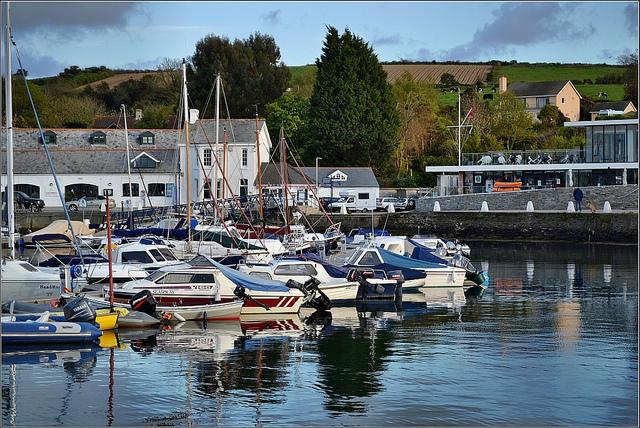Why is the hill above the sea brown with furrows? Please explain your reasoning. farm land. These types of markings are usually associated with planting crops. 